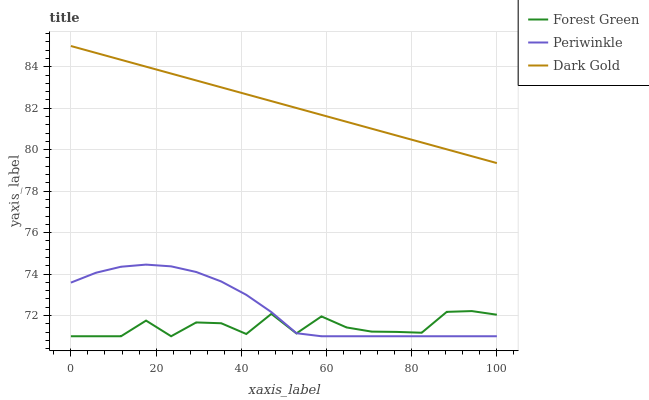Does Forest Green have the minimum area under the curve?
Answer yes or no. Yes. Does Dark Gold have the maximum area under the curve?
Answer yes or no. Yes. Does Periwinkle have the minimum area under the curve?
Answer yes or no. No. Does Periwinkle have the maximum area under the curve?
Answer yes or no. No. Is Dark Gold the smoothest?
Answer yes or no. Yes. Is Forest Green the roughest?
Answer yes or no. Yes. Is Periwinkle the smoothest?
Answer yes or no. No. Is Periwinkle the roughest?
Answer yes or no. No. Does Forest Green have the lowest value?
Answer yes or no. Yes. Does Dark Gold have the lowest value?
Answer yes or no. No. Does Dark Gold have the highest value?
Answer yes or no. Yes. Does Periwinkle have the highest value?
Answer yes or no. No. Is Forest Green less than Dark Gold?
Answer yes or no. Yes. Is Dark Gold greater than Periwinkle?
Answer yes or no. Yes. Does Forest Green intersect Periwinkle?
Answer yes or no. Yes. Is Forest Green less than Periwinkle?
Answer yes or no. No. Is Forest Green greater than Periwinkle?
Answer yes or no. No. Does Forest Green intersect Dark Gold?
Answer yes or no. No. 